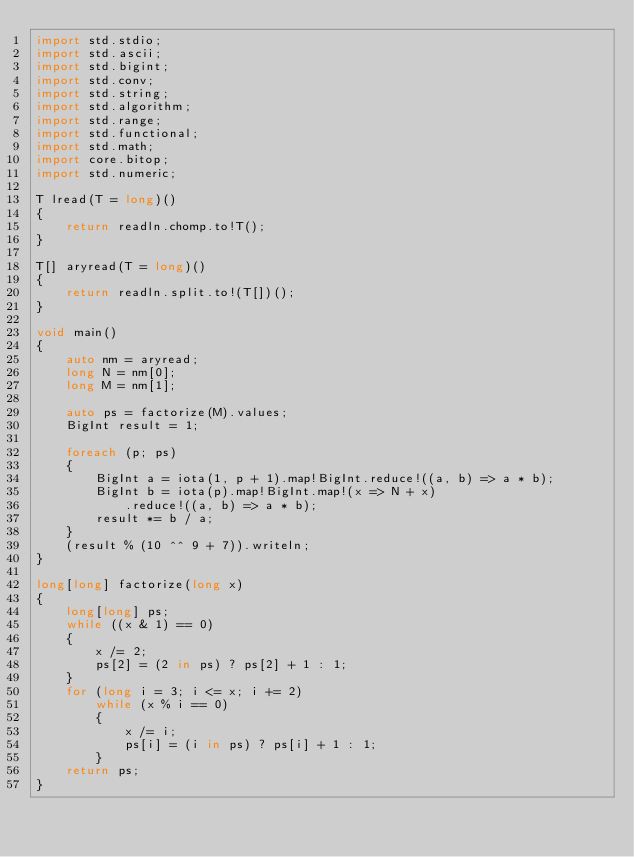Convert code to text. <code><loc_0><loc_0><loc_500><loc_500><_D_>import std.stdio;
import std.ascii;
import std.bigint;
import std.conv;
import std.string;
import std.algorithm;
import std.range;
import std.functional;
import std.math;
import core.bitop;
import std.numeric;

T lread(T = long)()
{
    return readln.chomp.to!T();
}

T[] aryread(T = long)()
{
    return readln.split.to!(T[])();
}

void main()
{
    auto nm = aryread;
    long N = nm[0];
    long M = nm[1];

    auto ps = factorize(M).values;
    BigInt result = 1;

    foreach (p; ps)
    {
        BigInt a = iota(1, p + 1).map!BigInt.reduce!((a, b) => a * b);
        BigInt b = iota(p).map!BigInt.map!(x => N + x)
            .reduce!((a, b) => a * b);
        result *= b / a;
    }
    (result % (10 ^^ 9 + 7)).writeln;
}

long[long] factorize(long x)
{
    long[long] ps;
    while ((x & 1) == 0)
    {
        x /= 2;
        ps[2] = (2 in ps) ? ps[2] + 1 : 1;
    }
    for (long i = 3; i <= x; i += 2)
        while (x % i == 0)
        {
            x /= i;
            ps[i] = (i in ps) ? ps[i] + 1 : 1;
        }
    return ps;
}
</code> 